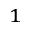Convert formula to latex. <formula><loc_0><loc_0><loc_500><loc_500>_ { 1 }</formula> 